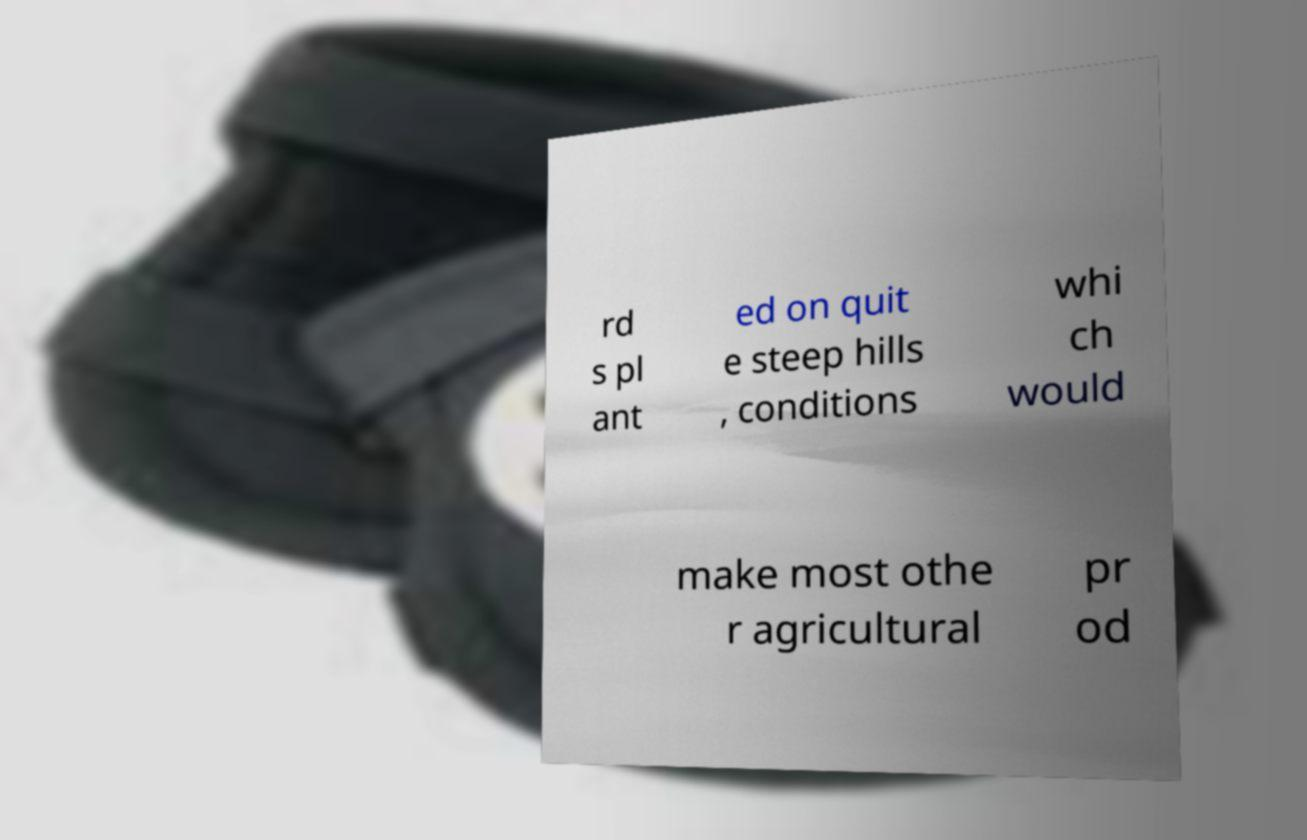Could you assist in decoding the text presented in this image and type it out clearly? rd s pl ant ed on quit e steep hills , conditions whi ch would make most othe r agricultural pr od 